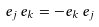<formula> <loc_0><loc_0><loc_500><loc_500>e _ { j } \, e _ { k } = - e _ { k } \, e _ { j }</formula> 